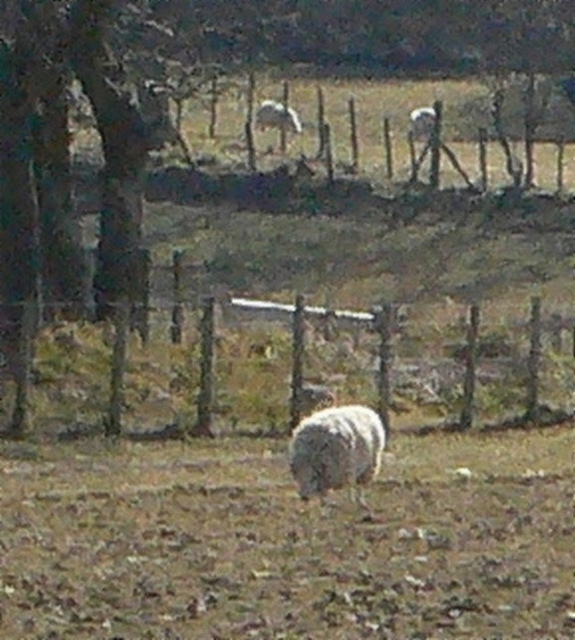<image>What is the wall made of? There is no wall in the image. It could be fencing made of wire and wood. What is the wall made of? The wall is made of either wood or wire. 